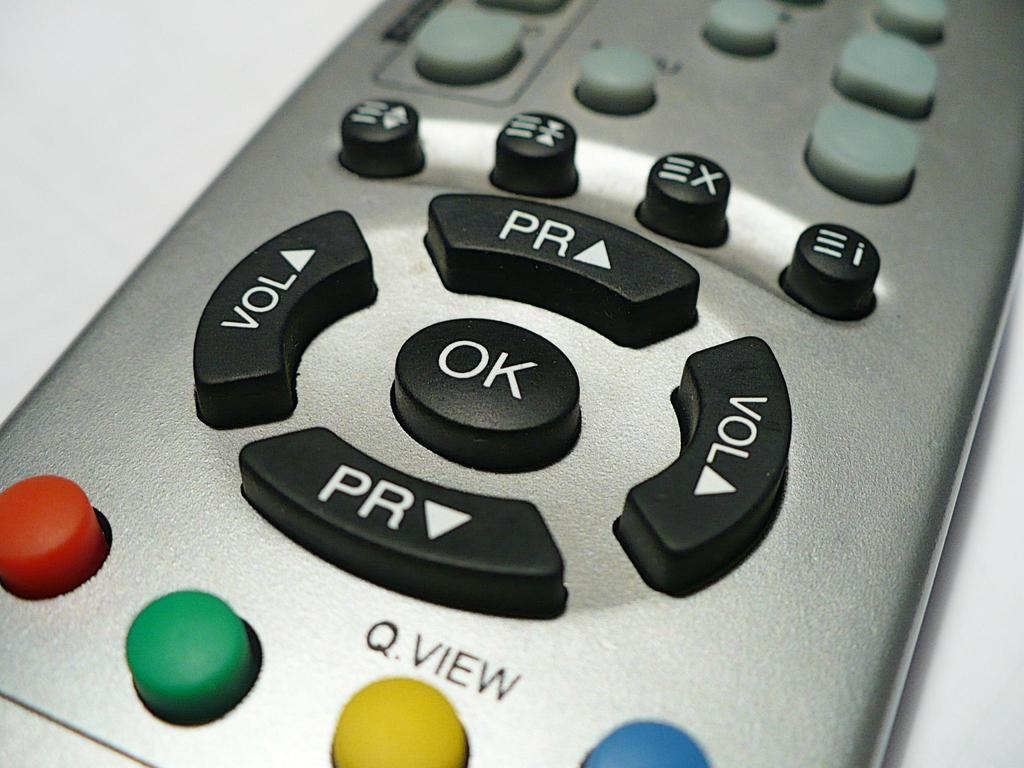<image>
Present a compact description of the photo's key features. A TV remote with buttons for raising and lowering the volume in black near the bottom. 